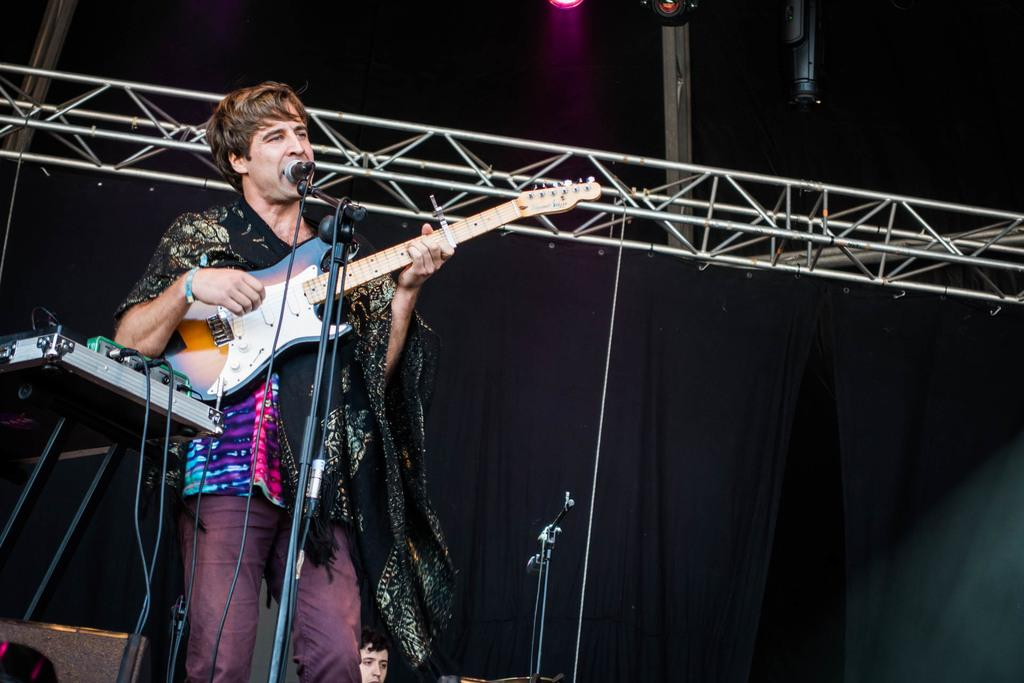What is the main subject of the image? There is a man in the image. What is the man doing in the image? The man is standing, singing, and holding a microphone and a guitar. What type of zipper is the man using to sing in the image? There is no zipper present in the image, and the man is singing using a microphone, not a zipper. 